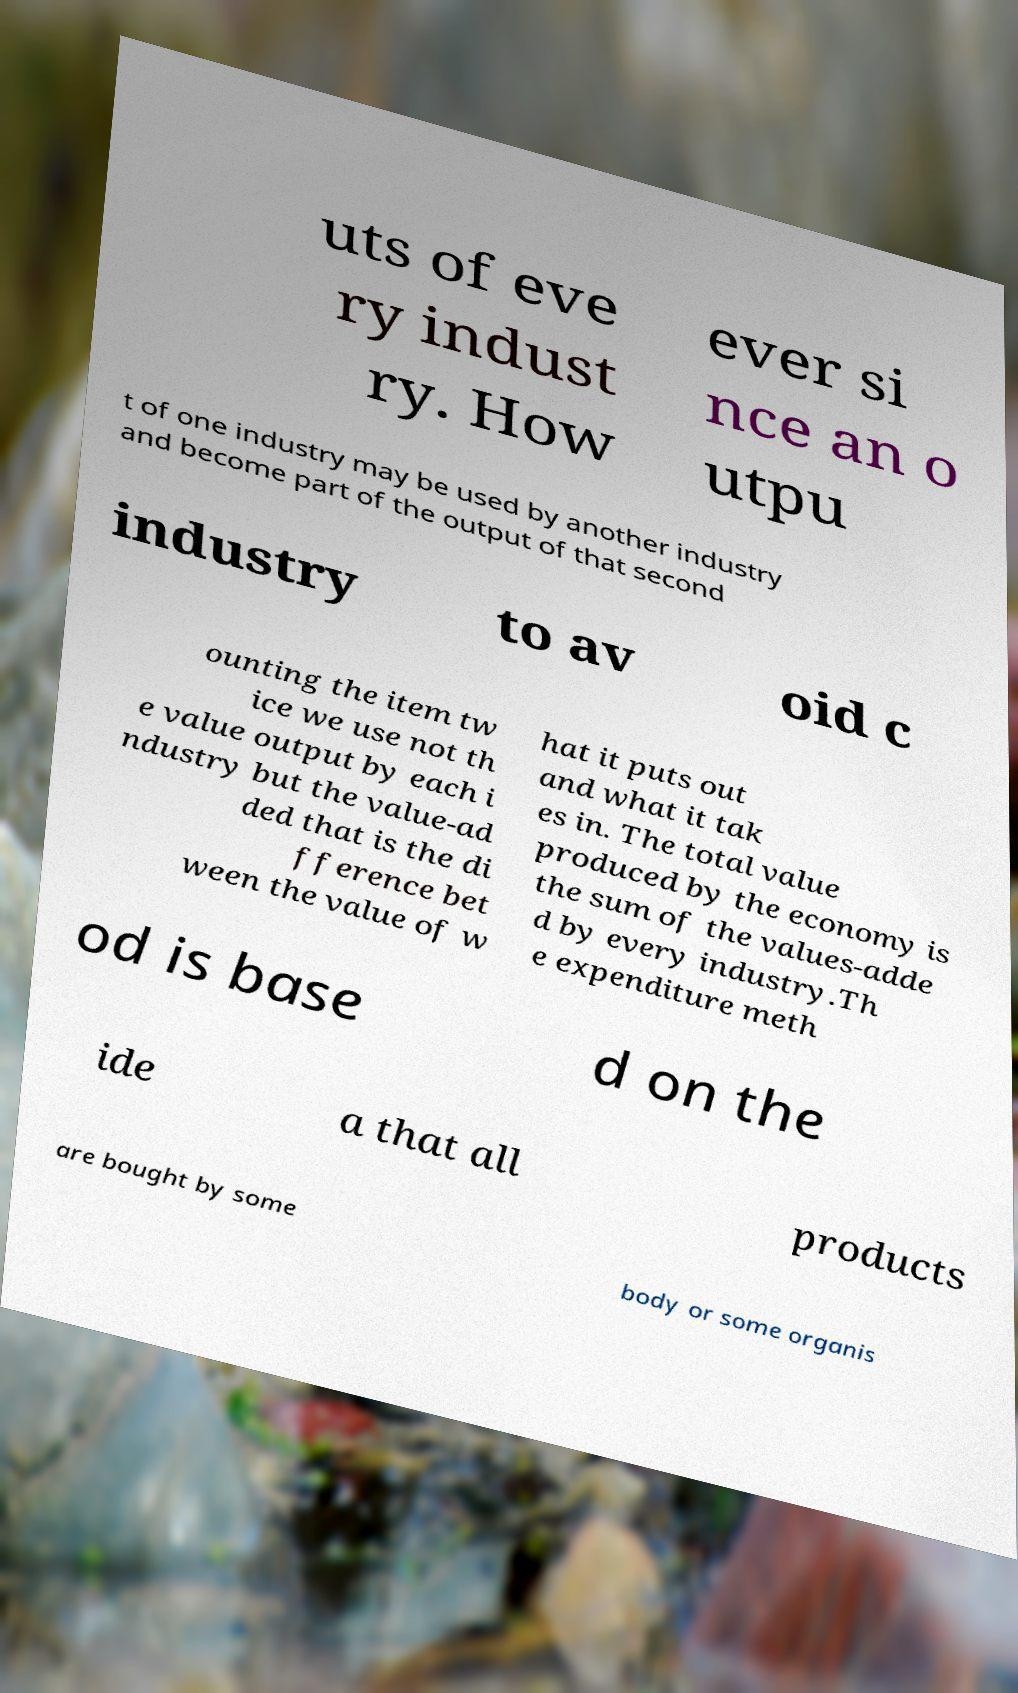Please identify and transcribe the text found in this image. uts of eve ry indust ry. How ever si nce an o utpu t of one industry may be used by another industry and become part of the output of that second industry to av oid c ounting the item tw ice we use not th e value output by each i ndustry but the value-ad ded that is the di fference bet ween the value of w hat it puts out and what it tak es in. The total value produced by the economy is the sum of the values-adde d by every industry.Th e expenditure meth od is base d on the ide a that all products are bought by some body or some organis 